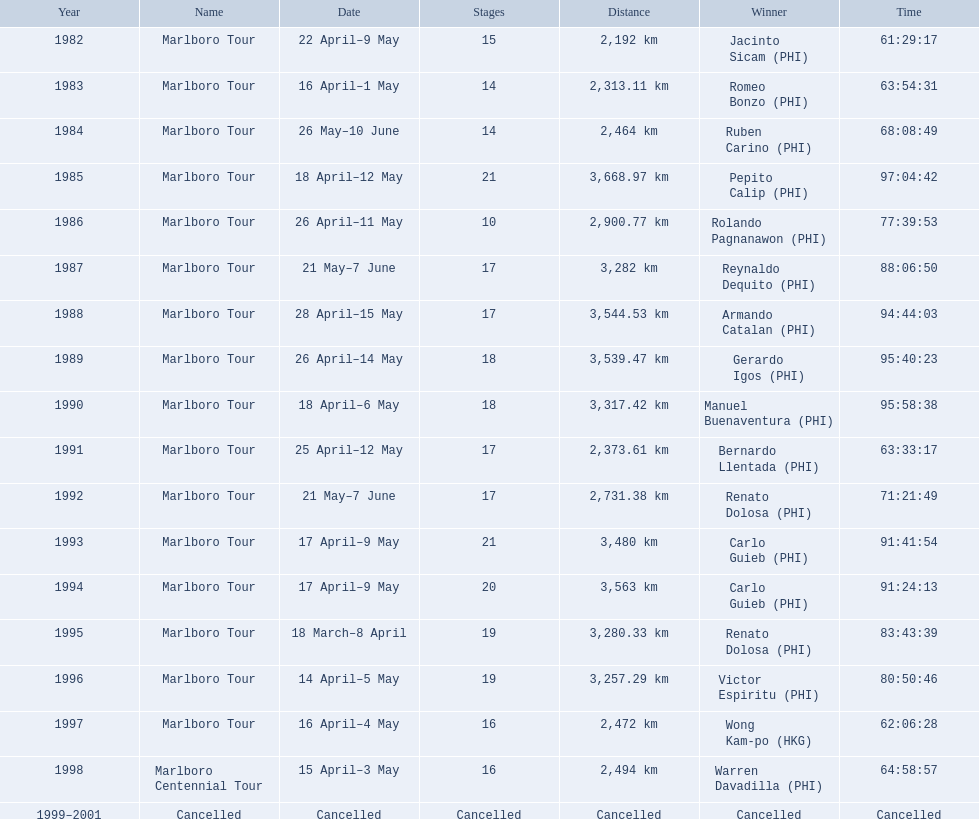Which competition did warren davadilla participate in in 1998? Marlboro Centennial Tour. How much time did it take davadilla to finish the marlboro centennial tour? 64:58:57. Who were all the champions? Jacinto Sicam (PHI), Romeo Bonzo (PHI), Ruben Carino (PHI), Pepito Calip (PHI), Rolando Pagnanawon (PHI), Reynaldo Dequito (PHI), Armando Catalan (PHI), Gerardo Igos (PHI), Manuel Buenaventura (PHI), Bernardo Llentada (PHI), Renato Dolosa (PHI), Carlo Guieb (PHI), Carlo Guieb (PHI), Renato Dolosa (PHI), Victor Espiritu (PHI), Wong Kam-po (HKG), Warren Davadilla (PHI), Cancelled. When did they contend? 1982, 1983, 1984, 1985, 1986, 1987, 1988, 1989, 1990, 1991, 1992, 1993, 1994, 1995, 1996, 1997, 1998, 1999–2001. What were their final times? 61:29:17, 63:54:31, 68:08:49, 97:04:42, 77:39:53, 88:06:50, 94:44:03, 95:40:23, 95:58:38, 63:33:17, 71:21:49, 91:41:54, 91:24:13, 83:43:39, 80:50:46, 62:06:28, 64:58:57, Cancelled. And who took the title in 1998? Warren Davadilla (PHI). What was his record? 64:58:57. Each year, how much distance did the marlboro tour traverse? 2,192 km, 2,313.11 km, 2,464 km, 3,668.97 km, 2,900.77 km, 3,282 km, 3,544.53 km, 3,539.47 km, 3,317.42 km, 2,373.61 km, 2,731.38 km, 3,480 km, 3,563 km, 3,280.33 km, 3,257.29 km, 2,472 km, 2,494 km, Cancelled. In what year was the longest distance achieved? 1985. What was the distance traveled in that particular year? 3,668.97 km. What year was warren davdilla (w.d.) present? 1998. Which tour did w.d. finish? Marlboro Centennial Tour. What is the time noted in the same row as w.d.? 64:58:57. 